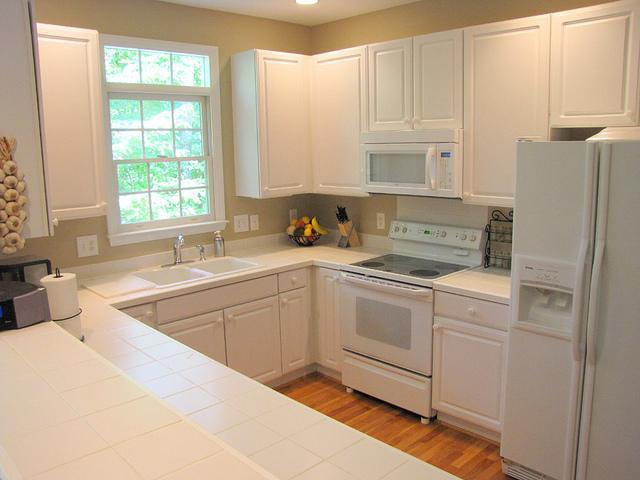How many windows are visible?
Give a very brief answer. 1. How many microwaves are in the photo?
Give a very brief answer. 1. 